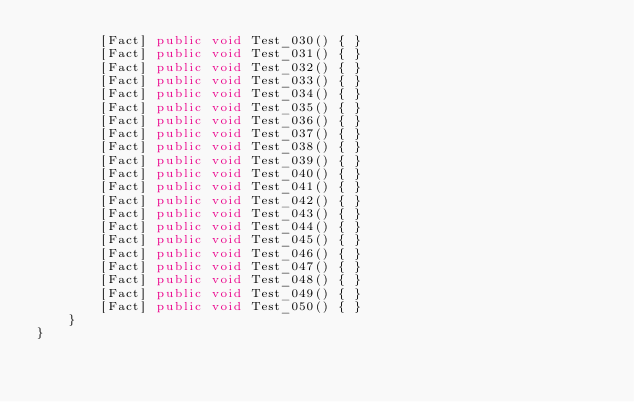<code> <loc_0><loc_0><loc_500><loc_500><_C#_>        [Fact] public void Test_030() { }
        [Fact] public void Test_031() { }
        [Fact] public void Test_032() { }
        [Fact] public void Test_033() { }
        [Fact] public void Test_034() { }
        [Fact] public void Test_035() { }
        [Fact] public void Test_036() { }
        [Fact] public void Test_037() { }
        [Fact] public void Test_038() { }
        [Fact] public void Test_039() { }
        [Fact] public void Test_040() { }
        [Fact] public void Test_041() { }
        [Fact] public void Test_042() { }
        [Fact] public void Test_043() { }
        [Fact] public void Test_044() { }
        [Fact] public void Test_045() { }
        [Fact] public void Test_046() { }
        [Fact] public void Test_047() { }
        [Fact] public void Test_048() { }
        [Fact] public void Test_049() { }
        [Fact] public void Test_050() { }
    }
}
</code> 